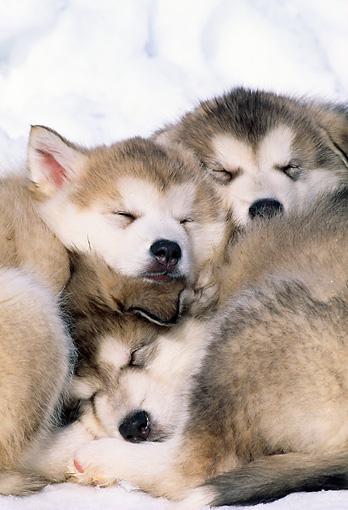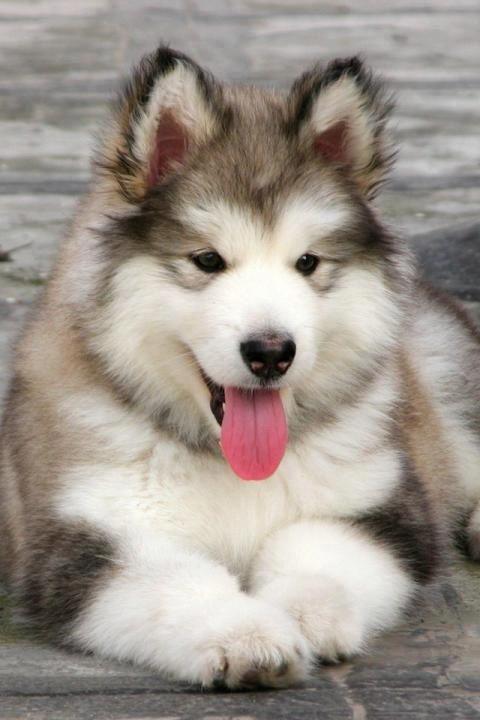The first image is the image on the left, the second image is the image on the right. For the images displayed, is the sentence "Four canines are visible." factually correct? Answer yes or no. Yes. The first image is the image on the left, the second image is the image on the right. Assess this claim about the two images: "A dog is on its back.". Correct or not? Answer yes or no. No. 